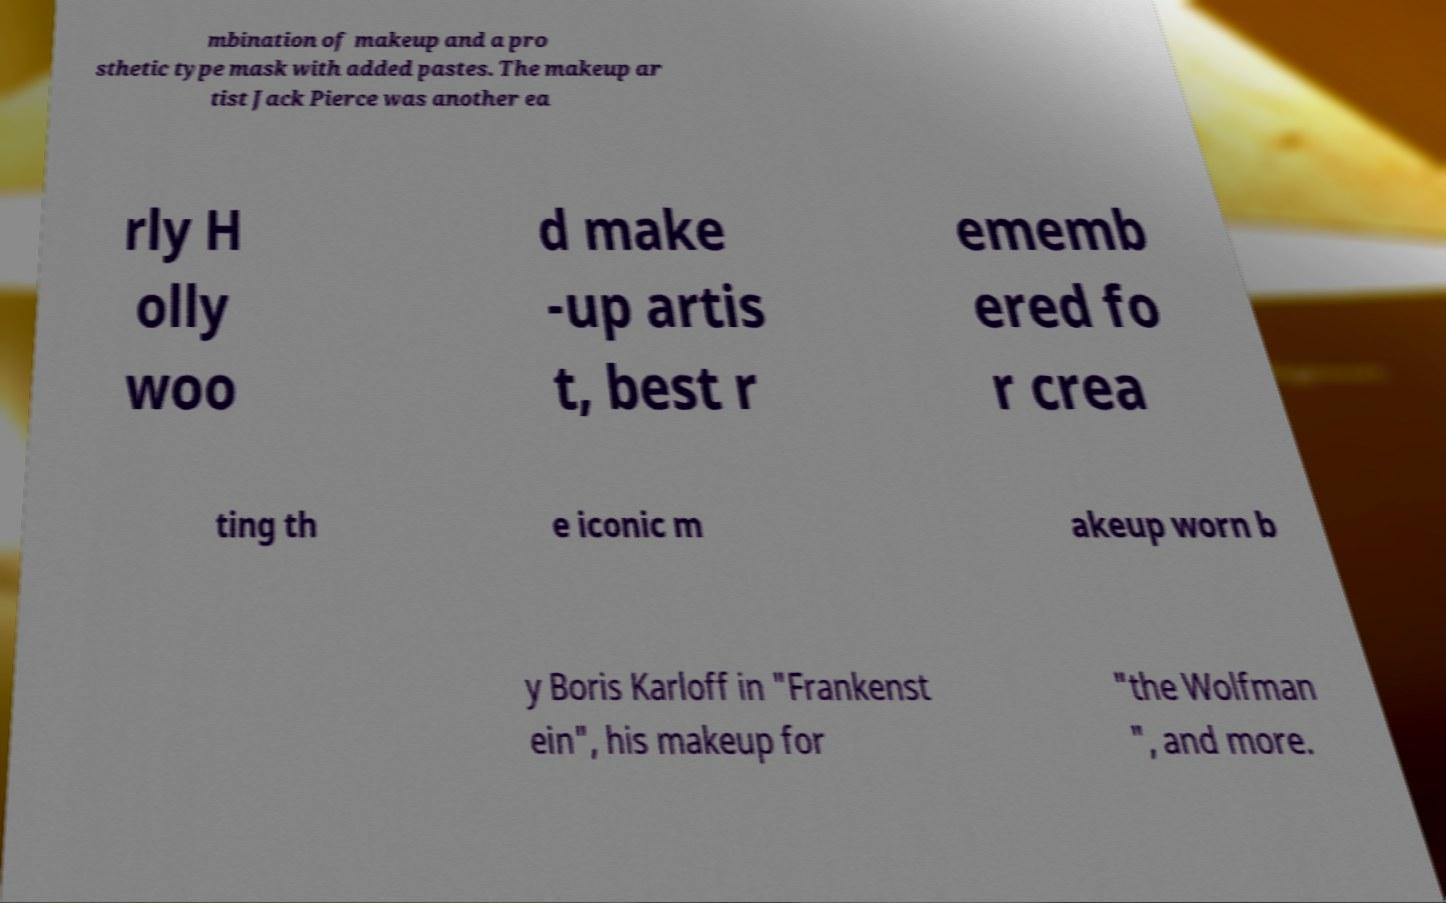Can you read and provide the text displayed in the image?This photo seems to have some interesting text. Can you extract and type it out for me? mbination of makeup and a pro sthetic type mask with added pastes. The makeup ar tist Jack Pierce was another ea rly H olly woo d make -up artis t, best r ememb ered fo r crea ting th e iconic m akeup worn b y Boris Karloff in "Frankenst ein", his makeup for "the Wolfman ", and more. 